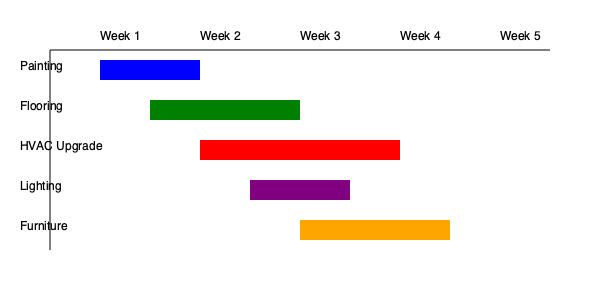Based on the Gantt chart for facility maintenance and upgrades, which task has the longest duration and when does it start? To determine the task with the longest duration and its start time, we need to analyze each task's bar length and position on the chart:

1. Painting: Starts at Week 1, spans about 1 week
2. Flooring: Starts midway through Week 1, spans about 1.5 weeks
3. HVAC Upgrade: Starts at Week 2, spans 2 weeks
4. Lighting: Starts midway through Week 2, spans about 1 week
5. Furniture: Starts at Week 3, spans about 1.5 weeks

Comparing the durations:
- HVAC Upgrade has the longest bar, spanning 2 full weeks
- The next longest are Flooring and Furniture, both spanning about 1.5 weeks
- Painting and Lighting have the shortest durations at about 1 week each

The HVAC Upgrade task has the longest duration, and it starts at the beginning of Week 2.
Answer: HVAC Upgrade, starting Week 2 